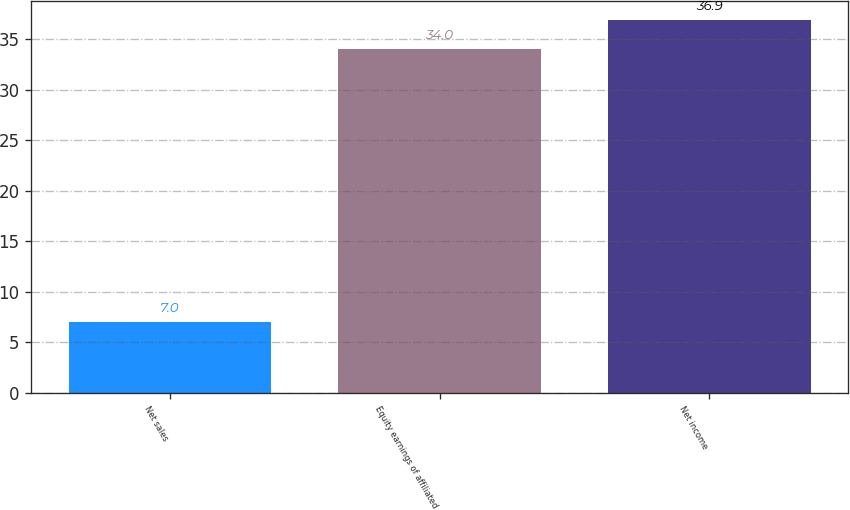Convert chart to OTSL. <chart><loc_0><loc_0><loc_500><loc_500><bar_chart><fcel>Net sales<fcel>Equity earnings of affiliated<fcel>Net income<nl><fcel>7<fcel>34<fcel>36.9<nl></chart> 